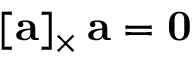<formula> <loc_0><loc_0><loc_500><loc_500>[ a ] _ { \times } \, a = 0</formula> 